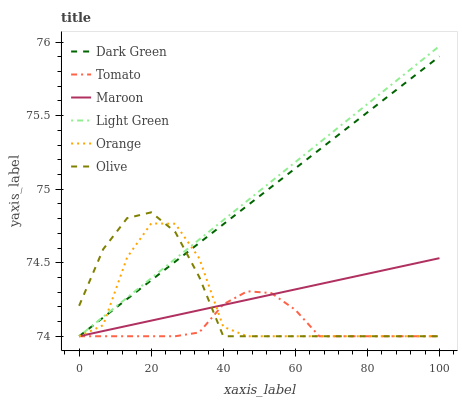Does Tomato have the minimum area under the curve?
Answer yes or no. Yes. Does Light Green have the maximum area under the curve?
Answer yes or no. Yes. Does Maroon have the minimum area under the curve?
Answer yes or no. No. Does Maroon have the maximum area under the curve?
Answer yes or no. No. Is Light Green the smoothest?
Answer yes or no. Yes. Is Orange the roughest?
Answer yes or no. Yes. Is Maroon the smoothest?
Answer yes or no. No. Is Maroon the roughest?
Answer yes or no. No. Does Maroon have the highest value?
Answer yes or no. No. 